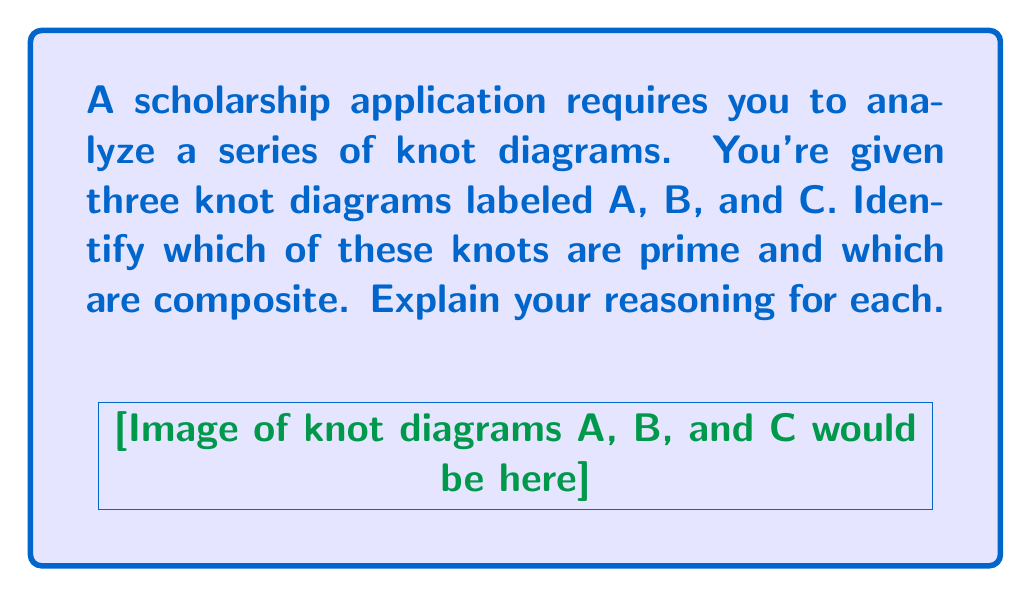Solve this math problem. To determine whether a knot is prime or composite, we need to analyze each diagram carefully:

1. Knot A (Trefoil knot):
   - This is a well-known prime knot.
   - It cannot be decomposed into simpler non-trivial knots.
   - The trefoil knot has a crossing number of 3, which is the minimum number of crossings for any non-trivial knot.

2. Knot B (Figure-eight knot):
   - This is also a prime knot.
   - It has a crossing number of 4 and cannot be decomposed into simpler non-trivial knots.
   - The figure-eight knot is the simplest non-trivial knot after the trefoil.

3. Knot C (Composite knot):
   - This knot is clearly composite.
   - It can be decomposed into two separate knots: a trefoil knot and an unknot (trivial knot).
   - The composition is evident from the diagram, where we can see a trefoil-like structure connected to a simple loop.

To summarize:
- Prime knots: A (Trefoil) and B (Figure-eight)
- Composite knot: C (Trefoil + Unknot)

Understanding prime and composite knots is crucial in knot theory, as prime knots serve as building blocks for more complex knots, similar to how prime numbers function in number theory.
Answer: A and B are prime; C is composite. 